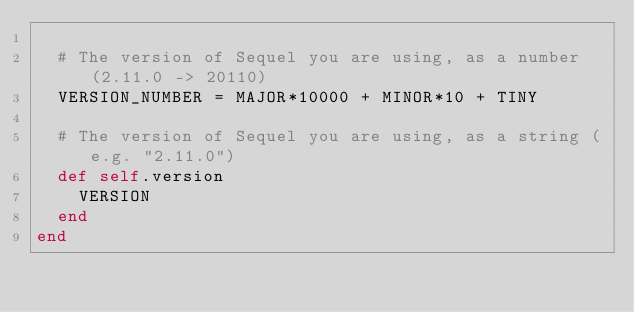<code> <loc_0><loc_0><loc_500><loc_500><_Ruby_>
  # The version of Sequel you are using, as a number (2.11.0 -> 20110)
  VERSION_NUMBER = MAJOR*10000 + MINOR*10 + TINY
  
  # The version of Sequel you are using, as a string (e.g. "2.11.0")
  def self.version
    VERSION
  end
end
</code> 